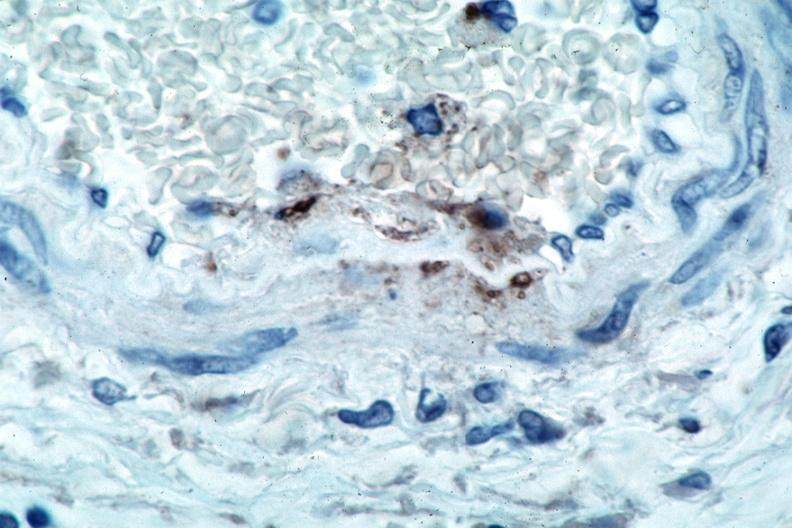what is vasculitis , rocky mountain spotted?
Answer the question using a single word or phrase. Fever immunoperoxidase staining vessels for rickettsia rickettsii 